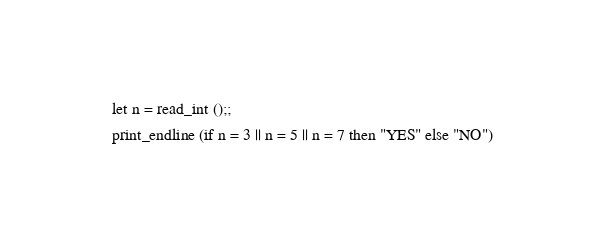<code> <loc_0><loc_0><loc_500><loc_500><_OCaml_>
let n = read_int ();;
print_endline (if n = 3 || n = 5 || n = 7 then "YES" else "NO")
</code> 